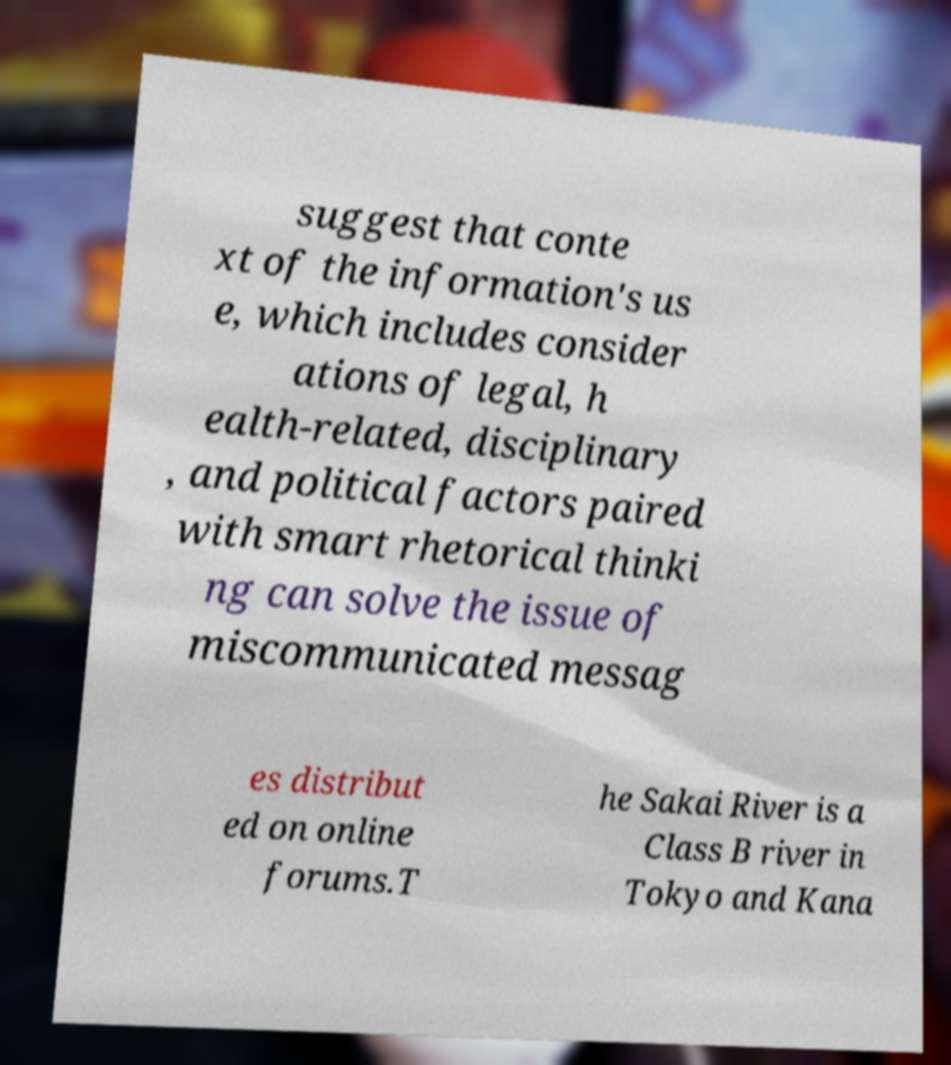Can you accurately transcribe the text from the provided image for me? suggest that conte xt of the information's us e, which includes consider ations of legal, h ealth-related, disciplinary , and political factors paired with smart rhetorical thinki ng can solve the issue of miscommunicated messag es distribut ed on online forums.T he Sakai River is a Class B river in Tokyo and Kana 